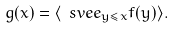<formula> <loc_0><loc_0><loc_500><loc_500>g ( x ) = \langle \ s v e e _ { y \leq x } f ( y ) \rangle .</formula> 